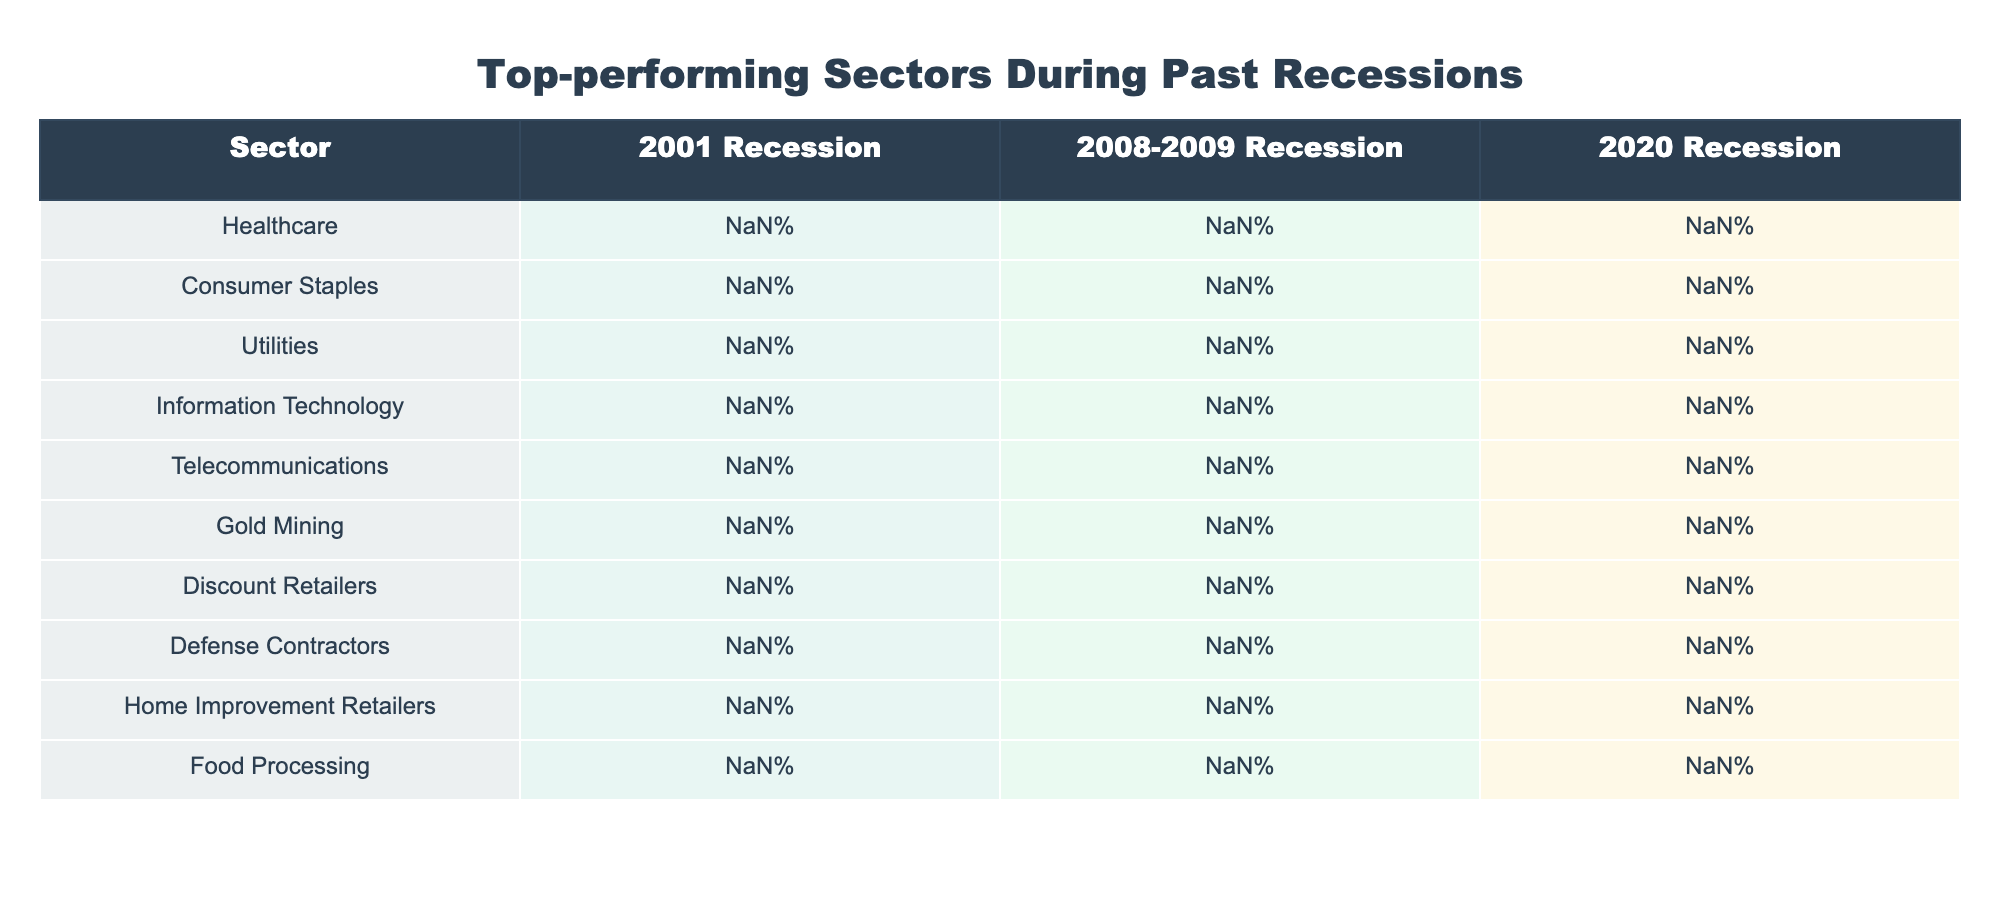What was the performance of Gold Mining during the 2008-2009 recession? According to the table, the performance of Gold Mining during the 2008-2009 recession was +26.3%.
Answer: +26.3% Which sector had the highest performance in the 2020 recession? In the table, Information Technology showed the highest performance during the 2020 recession with +43.9%.
Answer: +43.9% Did Utilities perform positively in any of the listed recessions? Looking at the table, Utilities had negative performances in all three recessions: -8.3% in 2001, -13.5% in 2008-2009, and -1.8% in 2020. Therefore, the answer is no.
Answer: No What are the average performance rates of the Consumer Staples sector across all three recessions? The performance rates of Consumer Staples are -1.2% for 2001, +1.8% for 2008-2009, and +7.6% for 2020. Adding these gives (-1.2 + 1.8 + 7.6) = 8.2%. To find the average, divide by 3, giving 8.2% / 3 = +2.73%.
Answer: +2.73% Which sector had the worst performance during the 2001 recession? From the table, Information Technology had the worst performance during the 2001 recession with -32.5%.
Answer: -32.5% What is the difference in performance between Home Improvement Retailers in 2008-2009 and 2020? Home Improvement Retailers had -23.8% in 2008-2009 and +21.3% in 2020. The difference is calculated as +21.3 - (-23.8) = +21.3 + 23.8 = +45.1%.
Answer: +45.1% Was Discount Retailers the top-performing sector in any recession listed? Analyzing the table, Discount Retailers had the highest performance during the 2008-2009 recession at +9.1%, but it was not the top performer in any of the listed recessions. Thus, the answer is no.
Answer: No Which sector showed consistent positive performance across all three recessions? By reviewing the table, Healthcare, Consumer Staples, Gold Mining, and Discount Retailers showed positive performances in at least one recession, but only Discount Retailers had positive performance in all three: +28.5%, +9.1%, and +34.7%. Therefore, the conclusion is that Discount Retailers had consistent positive performance.
Answer: Discount Retailers 